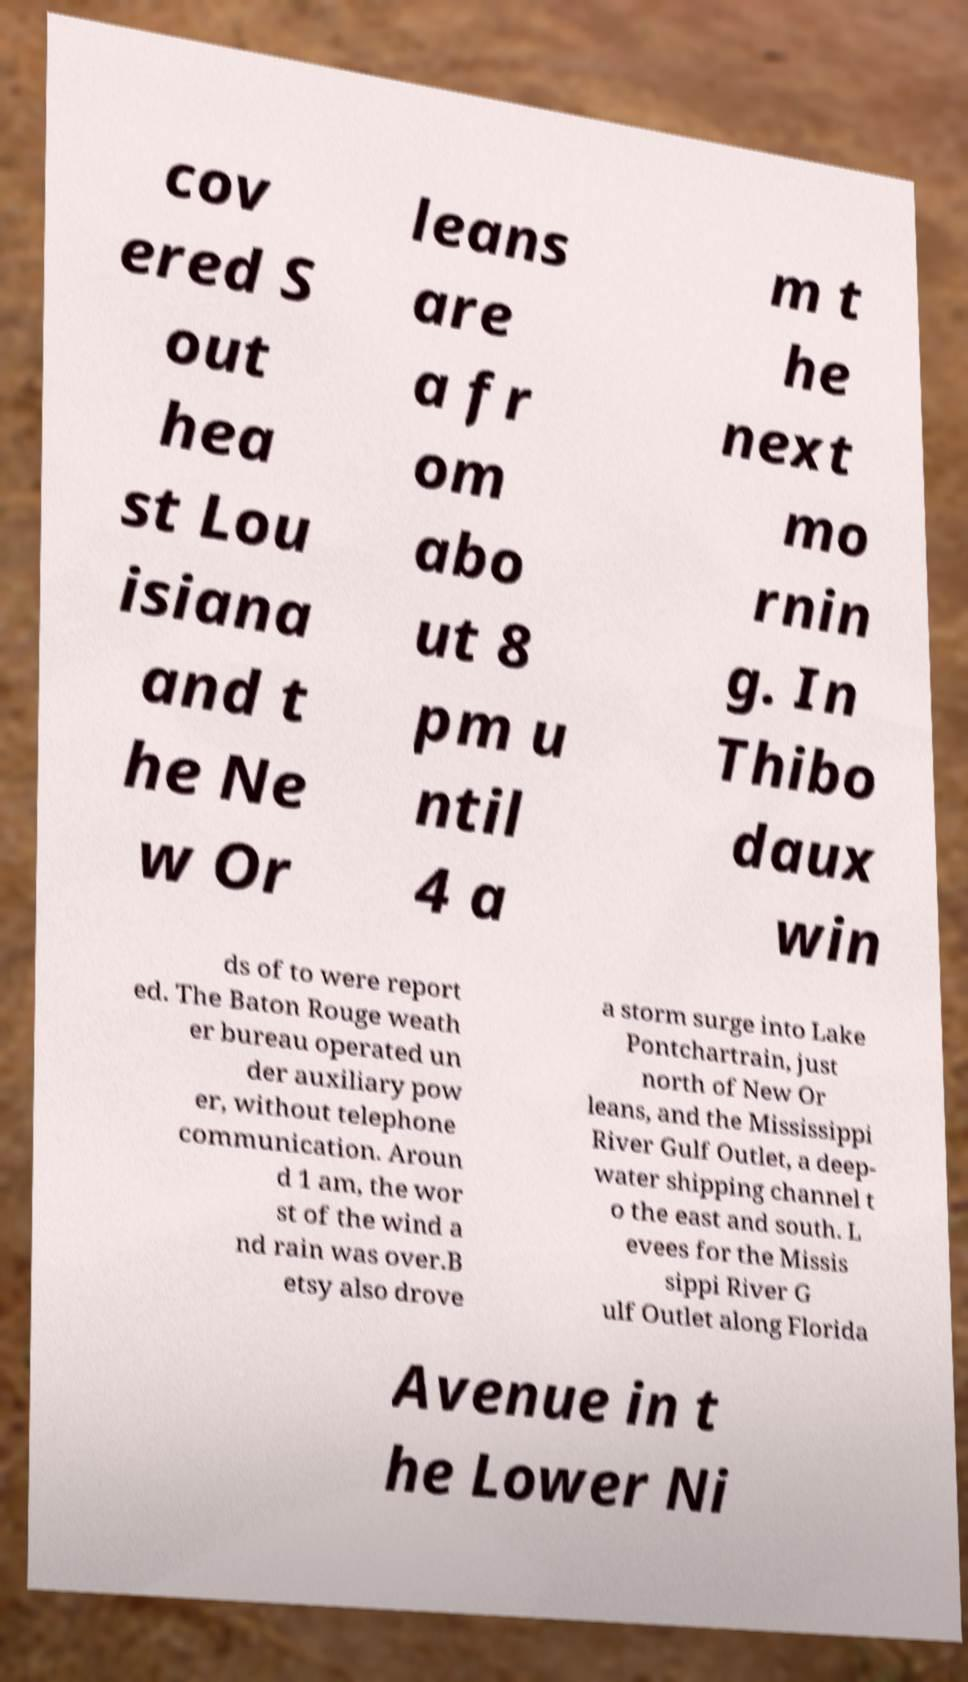For documentation purposes, I need the text within this image transcribed. Could you provide that? cov ered S out hea st Lou isiana and t he Ne w Or leans are a fr om abo ut 8 pm u ntil 4 a m t he next mo rnin g. In Thibo daux win ds of to were report ed. The Baton Rouge weath er bureau operated un der auxiliary pow er, without telephone communication. Aroun d 1 am, the wor st of the wind a nd rain was over.B etsy also drove a storm surge into Lake Pontchartrain, just north of New Or leans, and the Mississippi River Gulf Outlet, a deep- water shipping channel t o the east and south. L evees for the Missis sippi River G ulf Outlet along Florida Avenue in t he Lower Ni 